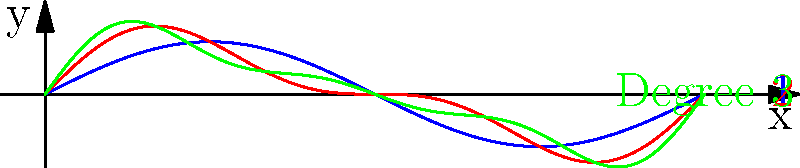As you plan your peaceful river cruise along the Loire Valley, you notice that the river's flow can be modeled using polynomial functions. The graph shows three curves representing different polynomial degrees modeling the river's flow. Which curve would likely provide the most serene and smooth sailing experience, aligning with your desire for a relaxing holiday? To determine which curve would provide the smoothest sailing experience, we need to analyze the characteristics of each curve:

1. Blue curve (Degree 1):
   - This is a simple sine wave, representing the most basic model.
   - It has smooth, consistent oscillations but lacks finer details.

2. Red curve (Degree 2):
   - This curve adds a second harmonic to the basic sine wave.
   - It shows more variation than the blue curve, with smaller peaks and troughs.

3. Green curve (Degree 3):
   - This curve incorporates a third harmonic.
   - It displays the most complex behavior, with additional small fluctuations.

For a serene and relaxing experience:
- We want to avoid sudden changes or sharp turns.
- A smoother, more predictable flow would be preferable.

The blue curve (Degree 1) offers the smoothest and most consistent flow. It has gentle, predictable oscillations without the additional fluctuations seen in the higher degree polynomials.

While the higher degree polynomials (red and green curves) might represent the river's flow more accurately, they introduce more variations that could potentially make the sailing experience less smooth and serene.

Therefore, for the most relaxing experience, the curve representing the lowest degree polynomial (blue curve, Degree 1) would be the best choice.
Answer: Degree 1 (blue curve) 